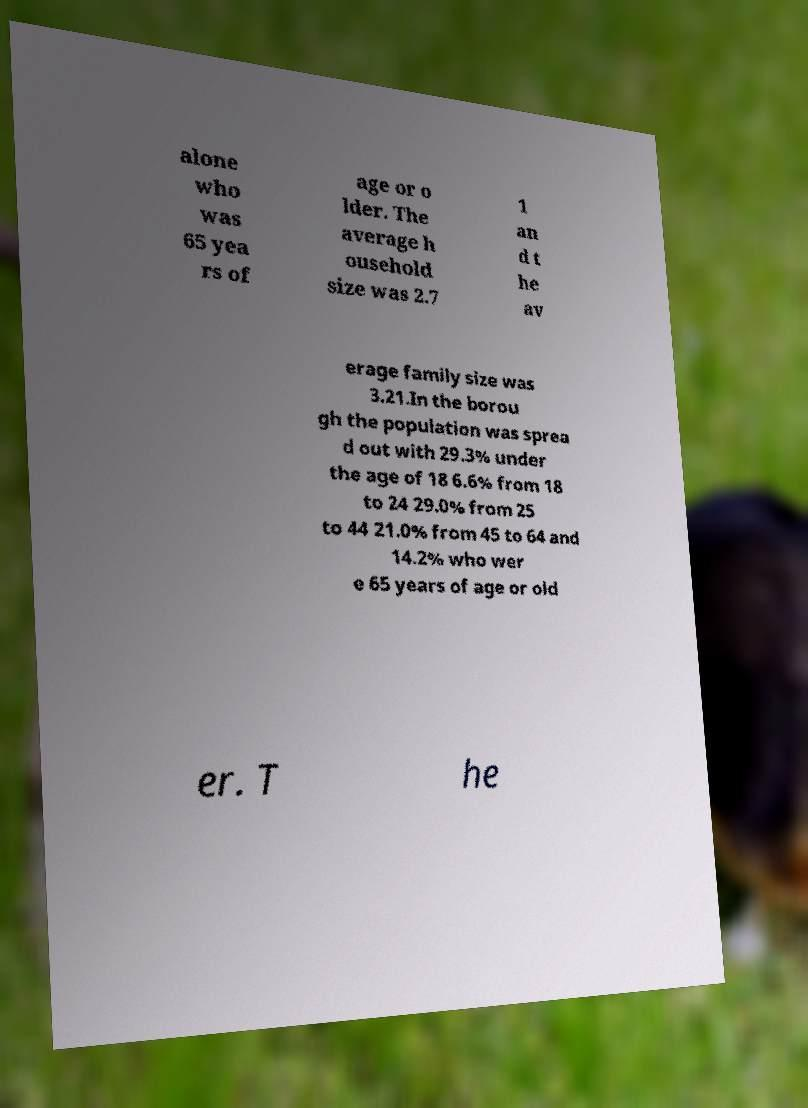There's text embedded in this image that I need extracted. Can you transcribe it verbatim? alone who was 65 yea rs of age or o lder. The average h ousehold size was 2.7 1 an d t he av erage family size was 3.21.In the borou gh the population was sprea d out with 29.3% under the age of 18 6.6% from 18 to 24 29.0% from 25 to 44 21.0% from 45 to 64 and 14.2% who wer e 65 years of age or old er. T he 